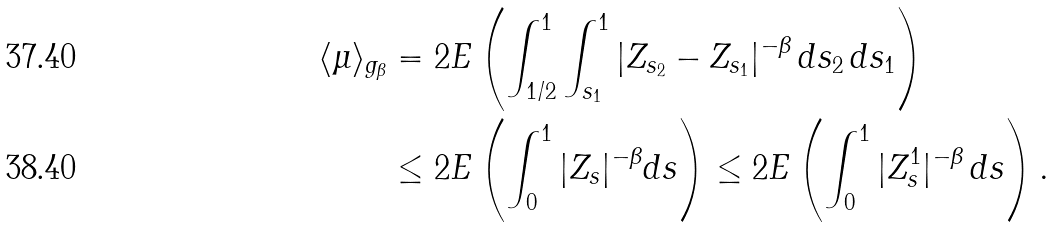<formula> <loc_0><loc_0><loc_500><loc_500>\langle \mu \rangle _ { g _ { \beta } } & = 2 E \left ( \int _ { 1 / 2 } ^ { 1 } \int _ { s _ { 1 } } ^ { 1 } | Z _ { s _ { 2 } } - Z _ { s _ { 1 } } | ^ { - \beta } \, d s _ { 2 } \, d s _ { 1 } \right ) \\ & \leq 2 E \left ( \int _ { 0 } ^ { 1 } | Z _ { s } | ^ { - \beta } d s \right ) \leq 2 E \left ( \int _ { 0 } ^ { 1 } | Z ^ { 1 } _ { s } | ^ { - \beta } \, d s \right ) .</formula> 